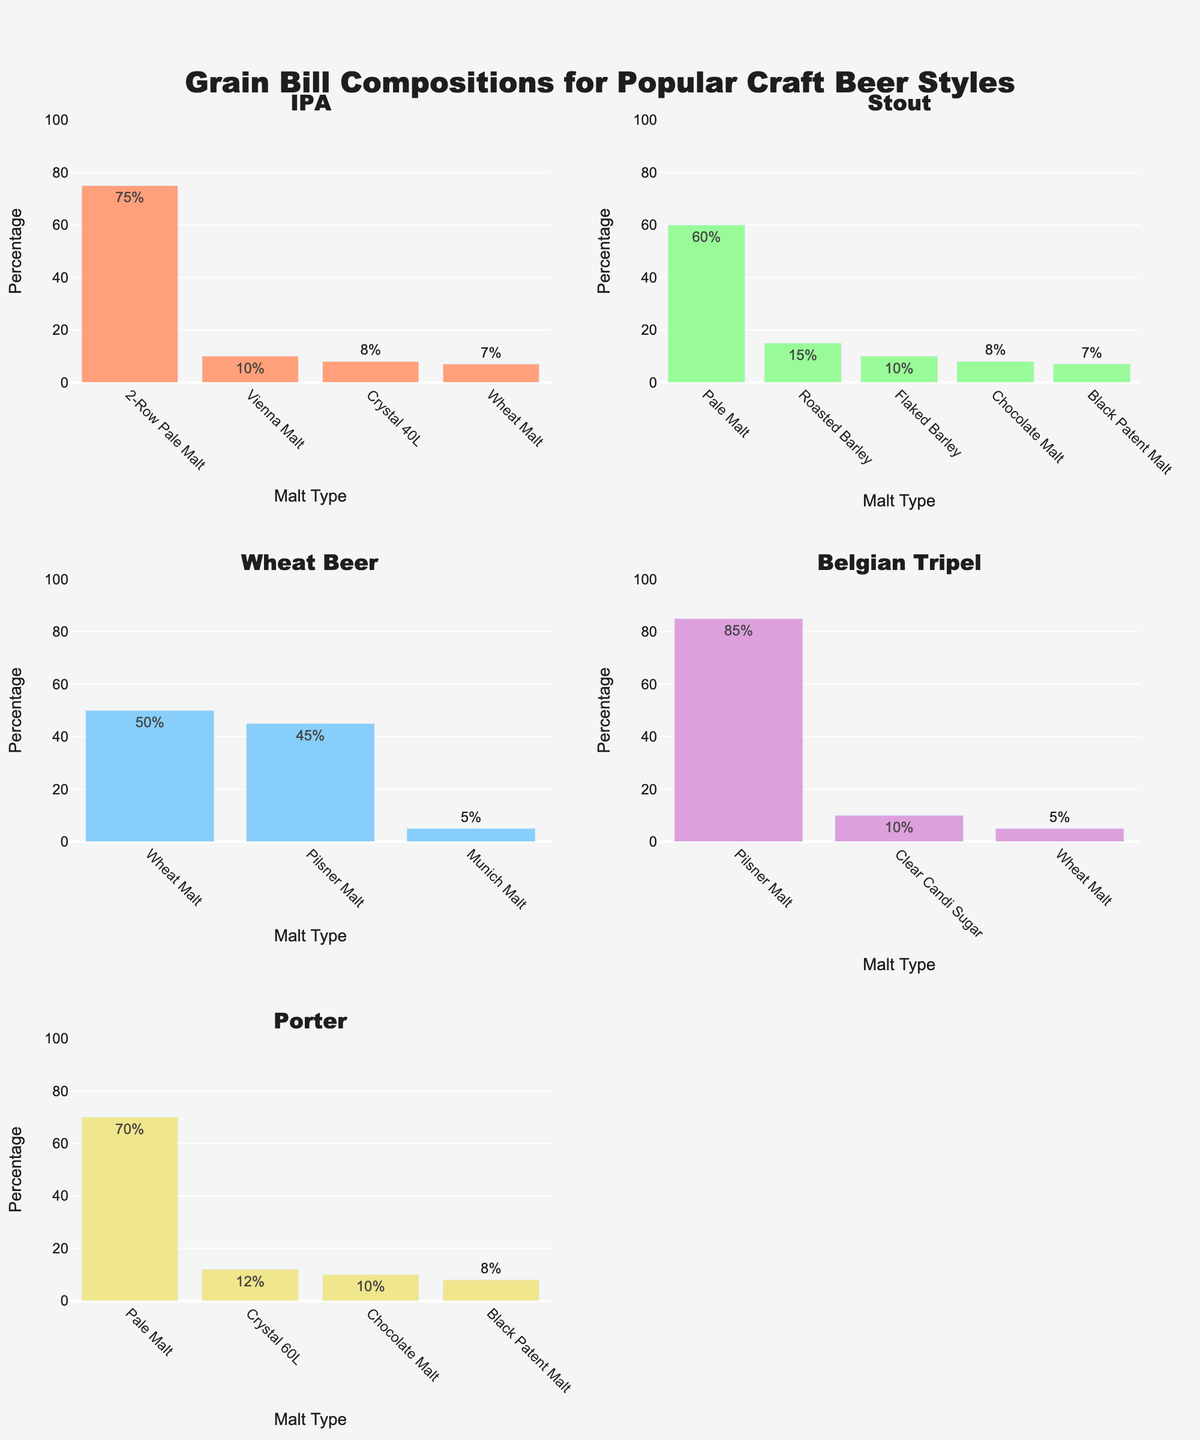Which beer style has the highest percentage of 2-Row Pale Malt? Look for 2-Row Pale Malt in the subplots and identify the beer style with the highest value.
Answer: IPA How many malt types are used in Stout? Count the different malt types listed for the Stout subplot.
Answer: 5 What's the dominant malt type in Belgian Tripel? Find the malt type with the highest percentage in the Belgian Tripel subplot.
Answer: Pilsner Malt Which beer style uses Clear Candi Sugar, and what is its percentage composition? Look across the subplots for Clear Candi Sugar and note the beer style and percentage.
Answer: Belgian Tripel, 10% What's the percentage difference between Pale Malt in Stout and Porter? Identify the percentages of Pale Malt in both Stout and Porter, and calculate the difference: 60% - 70% = -10%.
Answer: 10% Among the beer styles given, which one uses the least variety of malt types? Compare the number of different malt types across all beer style subplots.
Answer: Wheat Beer Which beer style uses Wheat Malt, and what's the highest percentage among them? Identify the beer styles using Wheat Malt and compare their percentages: 7% in IPA, 50% in Wheat Beer, and 5% in Belgian Tripel.
Answer: Wheat Beer, 50% What is the total percentage of malt types used in Porter? Sum all the percentages in the Porter subplot: 70% + 12% + 10% + 8% = 100%.
Answer: 100% How does the composition of Roasted Barley in Stout compare with Black Patent Malt in Porter? Compare the percentages of Roasted Barley in Stout (15%) with Black Patent Malt in Porter (8%).
Answer: Roasted Barley in Stout is higher Which malt type appears most frequently across all beer styles? Count the occurrences of each malt type in all subplots and identify the most frequent one.
Answer: Pale Malt 